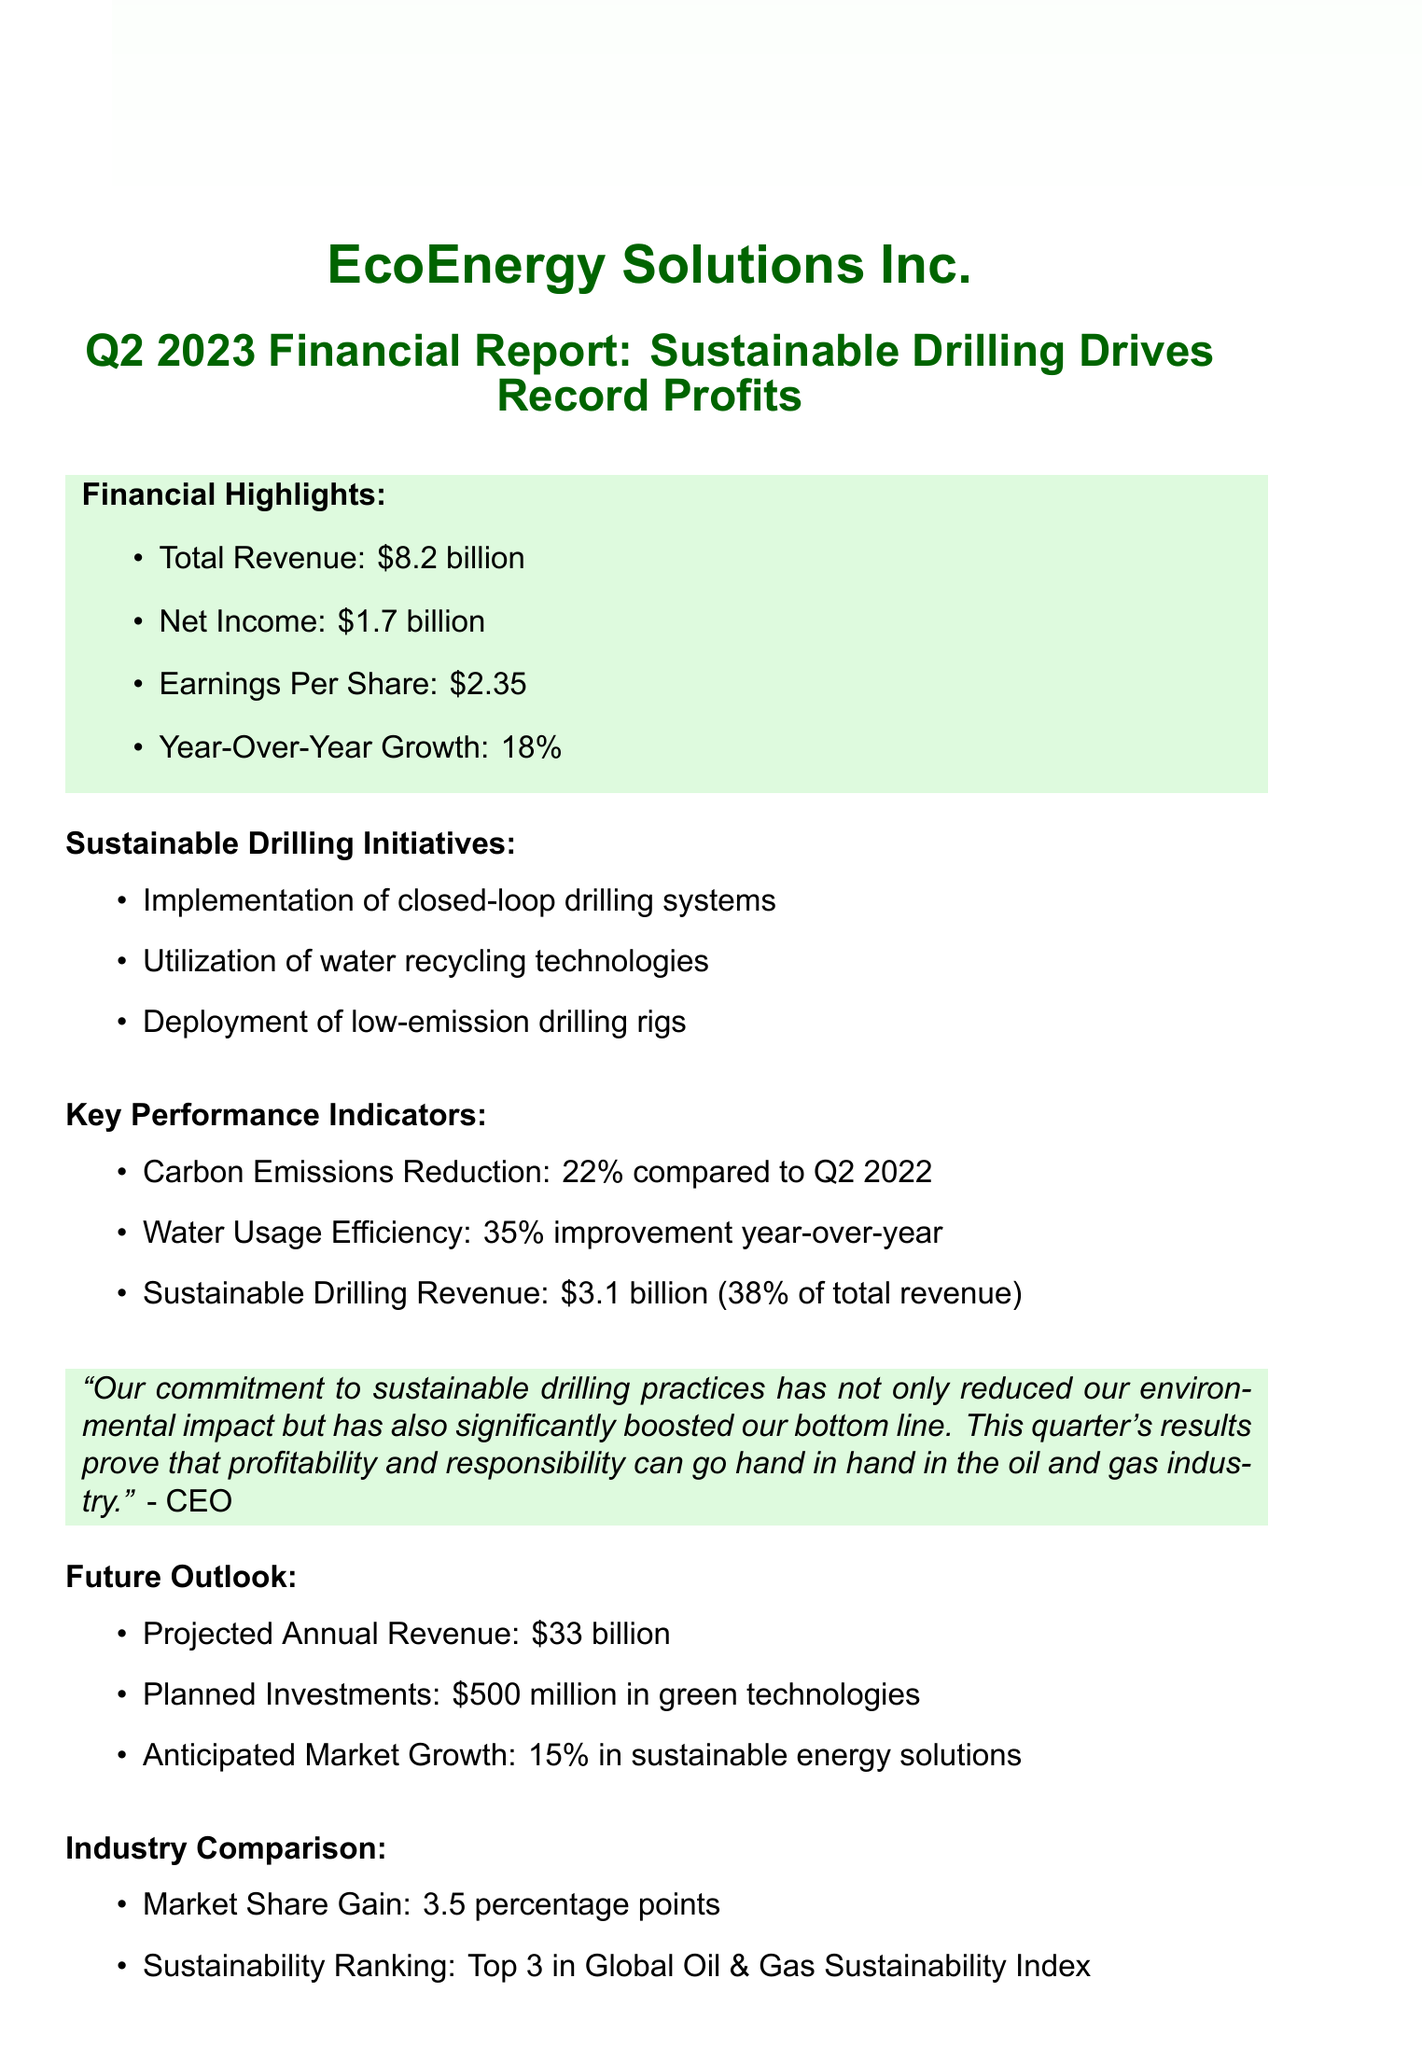What is the total revenue for Q2 2023? The total revenue represents the overall earnings of the company for the quarter, which is stated as $8.2 billion.
Answer: $8.2 billion What was the net income reported? The net income is the profit after expenses, and it is mentioned as $1.7 billion in the financial highlights.
Answer: $1.7 billion What percentage of total revenue comes from sustainable drilling? The document specifies that sustainable drilling revenue is $3.1 billion, which is 38% of the total revenue.
Answer: 38% How much has carbon emissions been reduced compared to Q2 2022? The report highlights a 22% reduction in carbon emissions relative to the same quarter of the previous year.
Answer: 22% What planned investment is mentioned for green technologies? The report indicates that the company plans to invest $500 million in green technologies.
Answer: $500 million What is this quarter's year-over-year growth? The year-over-year growth is highlighted in the financial highlights section, which states an increase of 18%.
Answer: 18% What is the projected annual revenue for the company? The report projects an annual revenue of $33 billion for the upcoming year.
Answer: $33 billion In which sustainability ranking does the company place? The document mentions that the company is ranked in the Top 3 in the Global Oil & Gas Sustainability Index.
Answer: Top 3 How much has water usage efficiency improved year-over-year? The improvement in water usage efficiency is stated as a 35% increase compared to the previous year.
Answer: 35% 